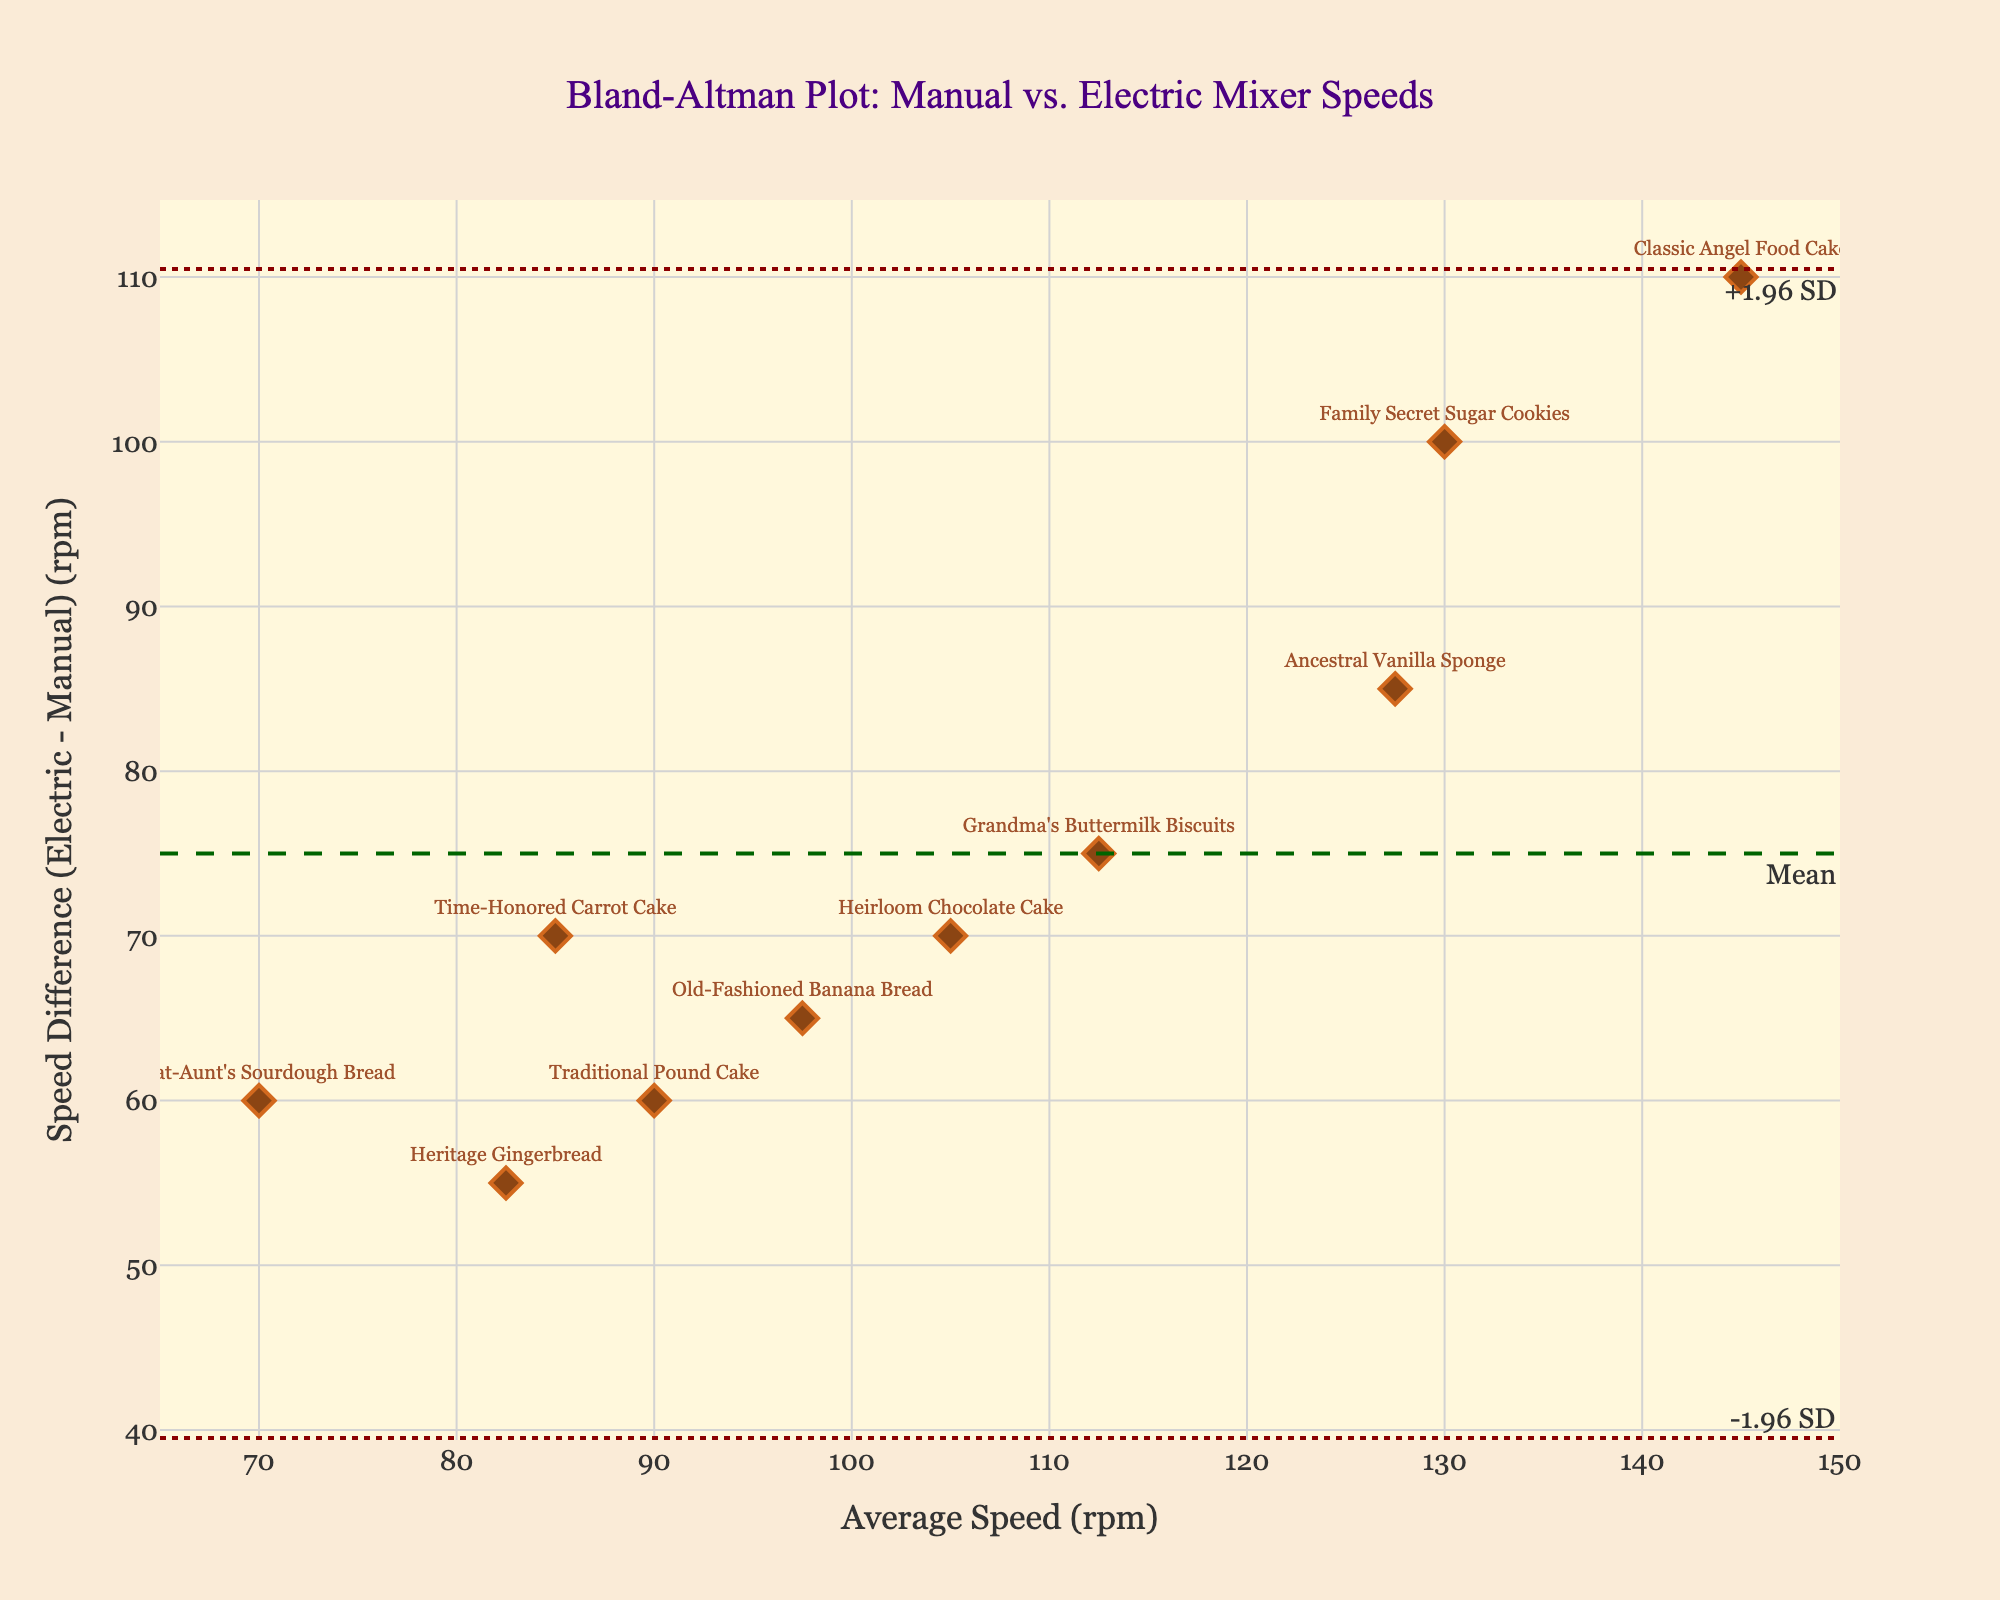what is the title of the plot? The title of the plot is displayed at the top center of the figure, written in a larger font size compared to other texts.
Answer: Bland-Altman Plot: Manual vs. Electric Mixer Speeds what is the average speed of Family Secret Sugar Cookies? Locate the data point labeled "Family Secret Sugar Cookies" and read the 'Average Speed (rpm)' value next to it.
Answer: 130 Which batter type has the highest speed difference? Identify the data point with the greatest 'Speed Difference (rpm)' value. The 'Family Secret Sugar Cookies' have the highest value.
Answer: Family Secret Sugar Cookies what is the speed difference for Great-Aunt's Sourdough Bread? Locate the point labeled with "Great-Aunt's Sourdough Bread" and see its 'Speed Difference (rpm)' value.
Answer: 60 are there any data points that lie on the mean difference line? Check if any data points have the same vertical position as the dashed 'Mean' line.
Answer: No how many data points fall outside the ±1.96 SD limits? Count the number of data points that are above the '+1.96 SD' line or below the '-1.96 SD' line.
Answer: 0 What is the difference between the highest and lowest average speed of batters? Find the maximum and minimum 'Average Speed (rpm)' values and subtract the minimum from the maximum.
Answer: 145 - 70 = 75 Which batter type has an average speed closest to the mean of all average speeds? Calculate the mean of all 'Average Speed (rpm)' values, then determine which batter type's average is closest to this calculated mean.
Answer: Old-Fashioned Banana Bread Which data point is farthest from the mean difference line? Identify the data point with the greatest vertical distance from the dashed ‘Mean’ line.
Answer: Classic Angel Food Cake What color are the data points? Observe the color used to represent the markers for the data points in the figure.
Answer: Brown 